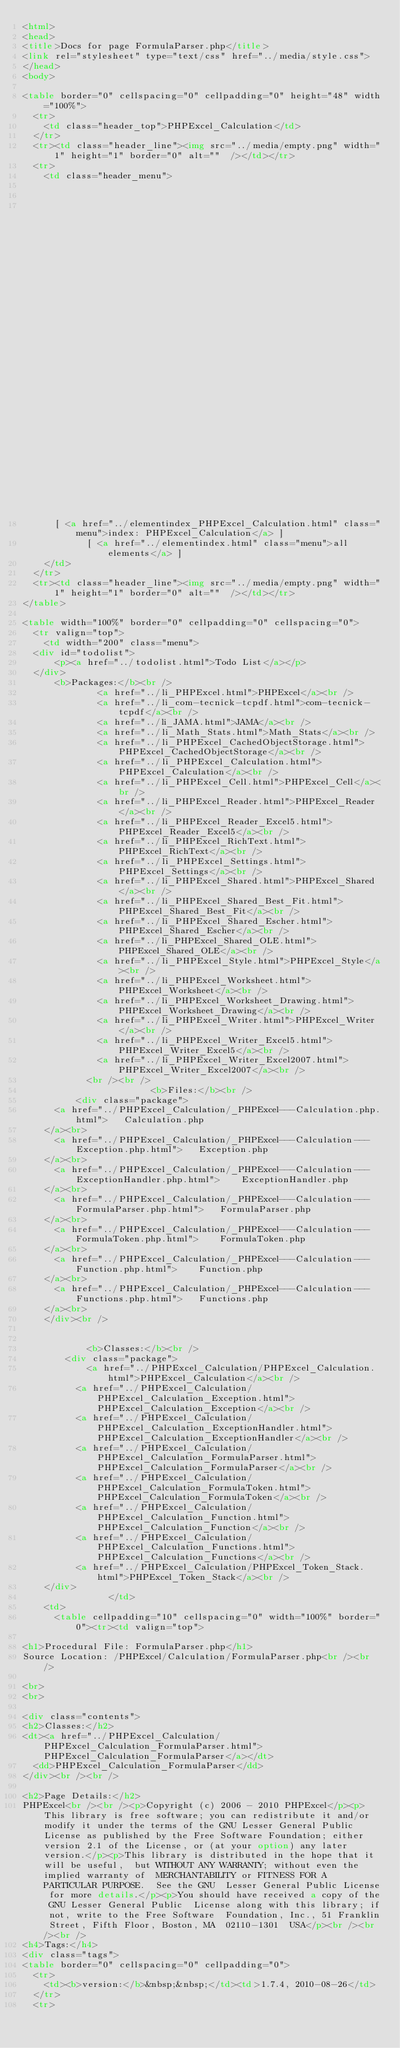Convert code to text. <code><loc_0><loc_0><loc_500><loc_500><_HTML_><html>
<head>
<title>Docs for page FormulaParser.php</title>
<link rel="stylesheet" type="text/css" href="../media/style.css">
</head>
<body>

<table border="0" cellspacing="0" cellpadding="0" height="48" width="100%">
  <tr>
    <td class="header_top">PHPExcel_Calculation</td>
  </tr>
  <tr><td class="header_line"><img src="../media/empty.png" width="1" height="1" border="0" alt=""  /></td></tr>
  <tr>
    <td class="header_menu">
        
                                                                                                                                        
                                                                                                                                                                                                                                                                                                                                          		  [ <a href="../classtrees_PHPExcel_Calculation.html" class="menu">class tree: PHPExcel_Calculation</a> ]
		  [ <a href="../elementindex_PHPExcel_Calculation.html" class="menu">index: PHPExcel_Calculation</a> ]
		  	    [ <a href="../elementindex.html" class="menu">all elements</a> ]
    </td>
  </tr>
  <tr><td class="header_line"><img src="../media/empty.png" width="1" height="1" border="0" alt=""  /></td></tr>
</table>

<table width="100%" border="0" cellpadding="0" cellspacing="0">
  <tr valign="top">
    <td width="200" class="menu">
	<div id="todolist">
			<p><a href="../todolist.html">Todo List</a></p>
	</div>
      <b>Packages:</b><br />
              <a href="../li_PHPExcel.html">PHPExcel</a><br />
              <a href="../li_com-tecnick-tcpdf.html">com-tecnick-tcpdf</a><br />
              <a href="../li_JAMA.html">JAMA</a><br />
              <a href="../li_Math_Stats.html">Math_Stats</a><br />
              <a href="../li_PHPExcel_CachedObjectStorage.html">PHPExcel_CachedObjectStorage</a><br />
              <a href="../li_PHPExcel_Calculation.html">PHPExcel_Calculation</a><br />
              <a href="../li_PHPExcel_Cell.html">PHPExcel_Cell</a><br />
              <a href="../li_PHPExcel_Reader.html">PHPExcel_Reader</a><br />
              <a href="../li_PHPExcel_Reader_Excel5.html">PHPExcel_Reader_Excel5</a><br />
              <a href="../li_PHPExcel_RichText.html">PHPExcel_RichText</a><br />
              <a href="../li_PHPExcel_Settings.html">PHPExcel_Settings</a><br />
              <a href="../li_PHPExcel_Shared.html">PHPExcel_Shared</a><br />
              <a href="../li_PHPExcel_Shared_Best_Fit.html">PHPExcel_Shared_Best_Fit</a><br />
              <a href="../li_PHPExcel_Shared_Escher.html">PHPExcel_Shared_Escher</a><br />
              <a href="../li_PHPExcel_Shared_OLE.html">PHPExcel_Shared_OLE</a><br />
              <a href="../li_PHPExcel_Style.html">PHPExcel_Style</a><br />
              <a href="../li_PHPExcel_Worksheet.html">PHPExcel_Worksheet</a><br />
              <a href="../li_PHPExcel_Worksheet_Drawing.html">PHPExcel_Worksheet_Drawing</a><br />
              <a href="../li_PHPExcel_Writer.html">PHPExcel_Writer</a><br />
              <a href="../li_PHPExcel_Writer_Excel5.html">PHPExcel_Writer_Excel5</a><br />
              <a href="../li_PHPExcel_Writer_Excel2007.html">PHPExcel_Writer_Excel2007</a><br />
            <br /><br />
                        <b>Files:</b><br />
      	  <div class="package">
			<a href="../PHPExcel_Calculation/_PHPExcel---Calculation.php.html">		Calculation.php
		</a><br>
			<a href="../PHPExcel_Calculation/_PHPExcel---Calculation---Exception.php.html">		Exception.php
		</a><br>
			<a href="../PHPExcel_Calculation/_PHPExcel---Calculation---ExceptionHandler.php.html">		ExceptionHandler.php
		</a><br>
			<a href="../PHPExcel_Calculation/_PHPExcel---Calculation---FormulaParser.php.html">		FormulaParser.php
		</a><br>
			<a href="../PHPExcel_Calculation/_PHPExcel---Calculation---FormulaToken.php.html">		FormulaToken.php
		</a><br>
			<a href="../PHPExcel_Calculation/_PHPExcel---Calculation---Function.php.html">		Function.php
		</a><br>
			<a href="../PHPExcel_Calculation/_PHPExcel---Calculation---Functions.php.html">		Functions.php
		</a><br>
	  </div><br />
      
      
            <b>Classes:</b><br />
        <div class="package">
		    		<a href="../PHPExcel_Calculation/PHPExcel_Calculation.html">PHPExcel_Calculation</a><br />
	    		<a href="../PHPExcel_Calculation/PHPExcel_Calculation_Exception.html">PHPExcel_Calculation_Exception</a><br />
	    		<a href="../PHPExcel_Calculation/PHPExcel_Calculation_ExceptionHandler.html">PHPExcel_Calculation_ExceptionHandler</a><br />
	    		<a href="../PHPExcel_Calculation/PHPExcel_Calculation_FormulaParser.html">PHPExcel_Calculation_FormulaParser</a><br />
	    		<a href="../PHPExcel_Calculation/PHPExcel_Calculation_FormulaToken.html">PHPExcel_Calculation_FormulaToken</a><br />
	    		<a href="../PHPExcel_Calculation/PHPExcel_Calculation_Function.html">PHPExcel_Calculation_Function</a><br />
	    		<a href="../PHPExcel_Calculation/PHPExcel_Calculation_Functions.html">PHPExcel_Calculation_Functions</a><br />
	    		<a href="../PHPExcel_Calculation/PHPExcel_Token_Stack.html">PHPExcel_Token_Stack</a><br />
	  </div>
                </td>
    <td>
      <table cellpadding="10" cellspacing="0" width="100%" border="0"><tr><td valign="top">

<h1>Procedural File: FormulaParser.php</h1>
Source Location: /PHPExcel/Calculation/FormulaParser.php<br /><br />

<br>
<br>

<div class="contents">
<h2>Classes:</h2>
<dt><a href="../PHPExcel_Calculation/PHPExcel_Calculation_FormulaParser.html">PHPExcel_Calculation_FormulaParser</a></dt>
	<dd>PHPExcel_Calculation_FormulaParser</dd>
</div><br /><br />

<h2>Page Details:</h2>
PHPExcel<br /><br /><p>Copyright (c) 2006 - 2010 PHPExcel</p><p>This library is free software; you can redistribute it and/or  modify it under the terms of the GNU Lesser General Public  License as published by the Free Software Foundation; either  version 2.1 of the License, or (at your option) any later version.</p><p>This library is distributed in the hope that it will be useful,  but WITHOUT ANY WARRANTY; without even the implied warranty of  MERCHANTABILITY or FITNESS FOR A PARTICULAR PURPOSE.  See the GNU  Lesser General Public License for more details.</p><p>You should have received a copy of the GNU Lesser General Public  License along with this library; if not, write to the Free Software  Foundation, Inc., 51 Franklin Street, Fifth Floor, Boston, MA  02110-1301  USA</p><br /><br /><br />
<h4>Tags:</h4>
<div class="tags">
<table border="0" cellspacing="0" cellpadding="0">
  <tr>
    <td><b>version:</b>&nbsp;&nbsp;</td><td>1.7.4, 2010-08-26</td>
  </tr>
  <tr></code> 